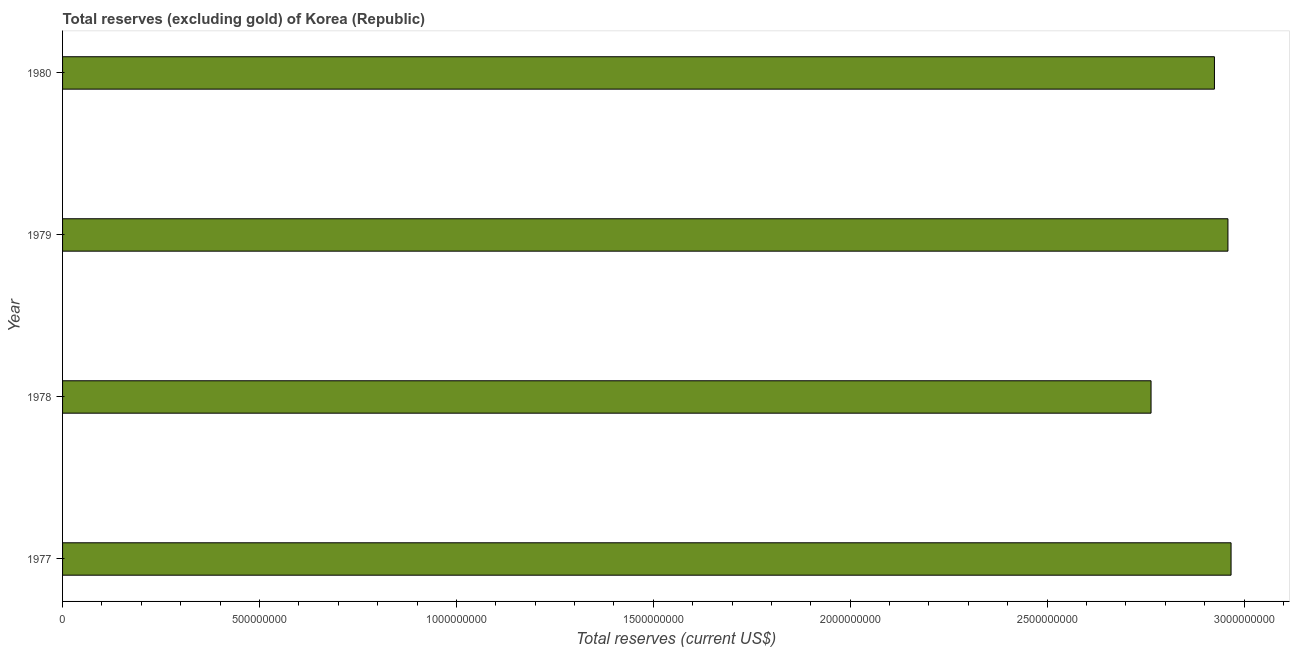Does the graph contain any zero values?
Offer a terse response. No. Does the graph contain grids?
Keep it short and to the point. No. What is the title of the graph?
Make the answer very short. Total reserves (excluding gold) of Korea (Republic). What is the label or title of the X-axis?
Offer a very short reply. Total reserves (current US$). What is the label or title of the Y-axis?
Keep it short and to the point. Year. What is the total reserves (excluding gold) in 1979?
Your response must be concise. 2.96e+09. Across all years, what is the maximum total reserves (excluding gold)?
Make the answer very short. 2.97e+09. Across all years, what is the minimum total reserves (excluding gold)?
Your answer should be compact. 2.76e+09. In which year was the total reserves (excluding gold) minimum?
Keep it short and to the point. 1978. What is the sum of the total reserves (excluding gold)?
Ensure brevity in your answer.  1.16e+1. What is the difference between the total reserves (excluding gold) in 1977 and 1978?
Your answer should be compact. 2.03e+08. What is the average total reserves (excluding gold) per year?
Offer a terse response. 2.90e+09. What is the median total reserves (excluding gold)?
Offer a very short reply. 2.94e+09. What is the ratio of the total reserves (excluding gold) in 1977 to that in 1978?
Your answer should be compact. 1.07. What is the difference between the highest and the second highest total reserves (excluding gold)?
Offer a very short reply. 7.93e+06. Is the sum of the total reserves (excluding gold) in 1977 and 1980 greater than the maximum total reserves (excluding gold) across all years?
Your response must be concise. Yes. What is the difference between the highest and the lowest total reserves (excluding gold)?
Ensure brevity in your answer.  2.03e+08. What is the Total reserves (current US$) in 1977?
Provide a short and direct response. 2.97e+09. What is the Total reserves (current US$) in 1978?
Your answer should be compact. 2.76e+09. What is the Total reserves (current US$) in 1979?
Make the answer very short. 2.96e+09. What is the Total reserves (current US$) in 1980?
Keep it short and to the point. 2.92e+09. What is the difference between the Total reserves (current US$) in 1977 and 1978?
Offer a very short reply. 2.03e+08. What is the difference between the Total reserves (current US$) in 1977 and 1979?
Offer a terse response. 7.93e+06. What is the difference between the Total reserves (current US$) in 1977 and 1980?
Your answer should be very brief. 4.22e+07. What is the difference between the Total reserves (current US$) in 1978 and 1979?
Make the answer very short. -1.95e+08. What is the difference between the Total reserves (current US$) in 1978 and 1980?
Provide a short and direct response. -1.61e+08. What is the difference between the Total reserves (current US$) in 1979 and 1980?
Make the answer very short. 3.43e+07. What is the ratio of the Total reserves (current US$) in 1977 to that in 1978?
Your answer should be very brief. 1.07. What is the ratio of the Total reserves (current US$) in 1977 to that in 1979?
Your response must be concise. 1. What is the ratio of the Total reserves (current US$) in 1977 to that in 1980?
Keep it short and to the point. 1.01. What is the ratio of the Total reserves (current US$) in 1978 to that in 1979?
Make the answer very short. 0.93. What is the ratio of the Total reserves (current US$) in 1978 to that in 1980?
Your answer should be compact. 0.94. 